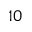Convert formula to latex. <formula><loc_0><loc_0><loc_500><loc_500>1 0</formula> 